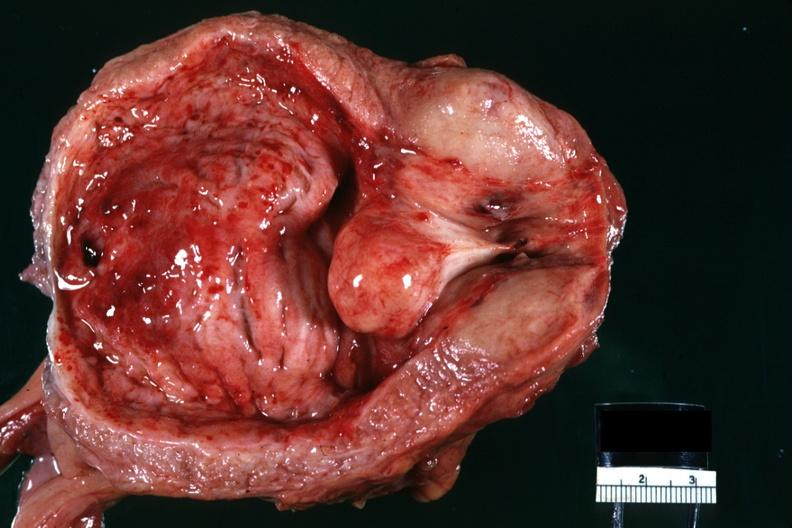does this image show close-up median lobe hyperplasia so-called median bar lesion very good hemorrhagic cystitis?
Answer the question using a single word or phrase. Yes 